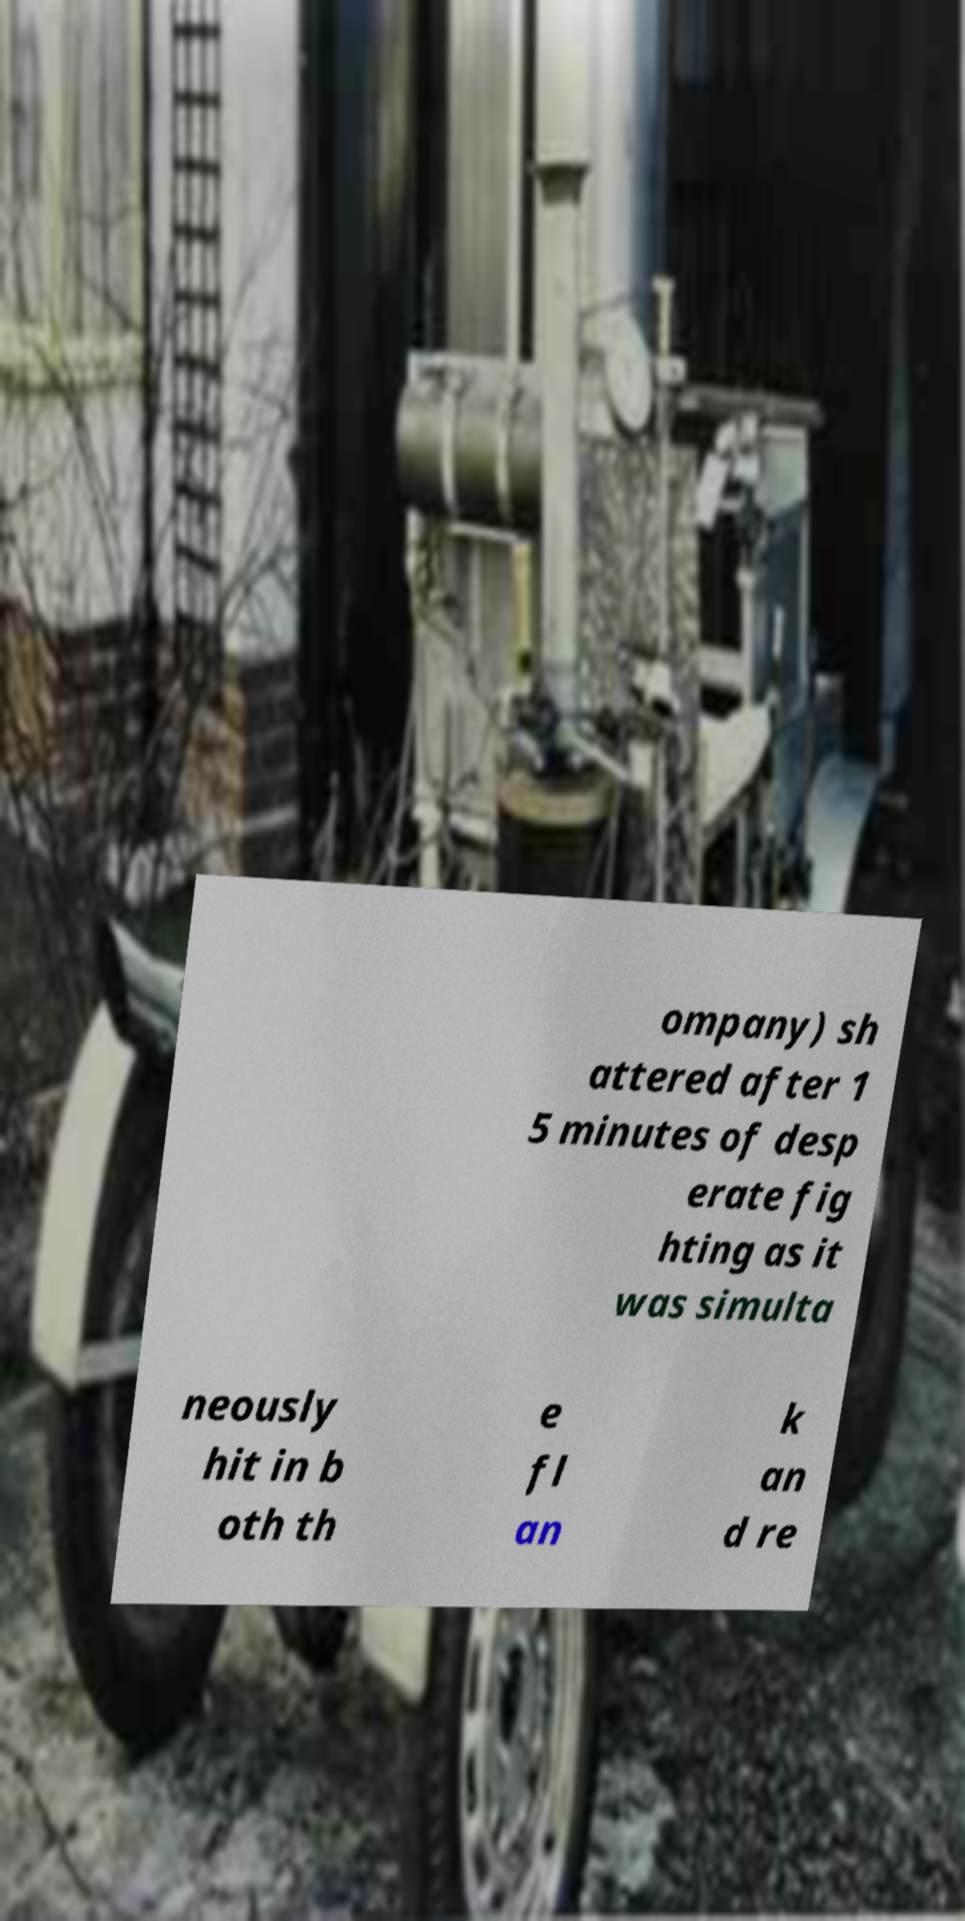Please read and relay the text visible in this image. What does it say? ompany) sh attered after 1 5 minutes of desp erate fig hting as it was simulta neously hit in b oth th e fl an k an d re 